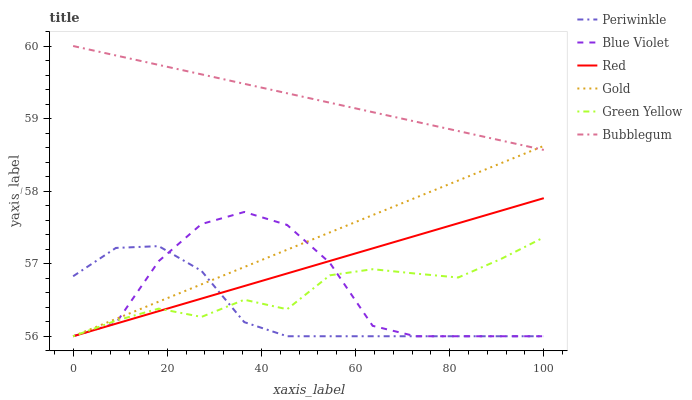Does Periwinkle have the minimum area under the curve?
Answer yes or no. Yes. Does Bubblegum have the maximum area under the curve?
Answer yes or no. Yes. Does Bubblegum have the minimum area under the curve?
Answer yes or no. No. Does Periwinkle have the maximum area under the curve?
Answer yes or no. No. Is Gold the smoothest?
Answer yes or no. Yes. Is Blue Violet the roughest?
Answer yes or no. Yes. Is Bubblegum the smoothest?
Answer yes or no. No. Is Bubblegum the roughest?
Answer yes or no. No. Does Gold have the lowest value?
Answer yes or no. Yes. Does Bubblegum have the lowest value?
Answer yes or no. No. Does Bubblegum have the highest value?
Answer yes or no. Yes. Does Periwinkle have the highest value?
Answer yes or no. No. Is Red less than Bubblegum?
Answer yes or no. Yes. Is Bubblegum greater than Blue Violet?
Answer yes or no. Yes. Does Gold intersect Blue Violet?
Answer yes or no. Yes. Is Gold less than Blue Violet?
Answer yes or no. No. Is Gold greater than Blue Violet?
Answer yes or no. No. Does Red intersect Bubblegum?
Answer yes or no. No. 